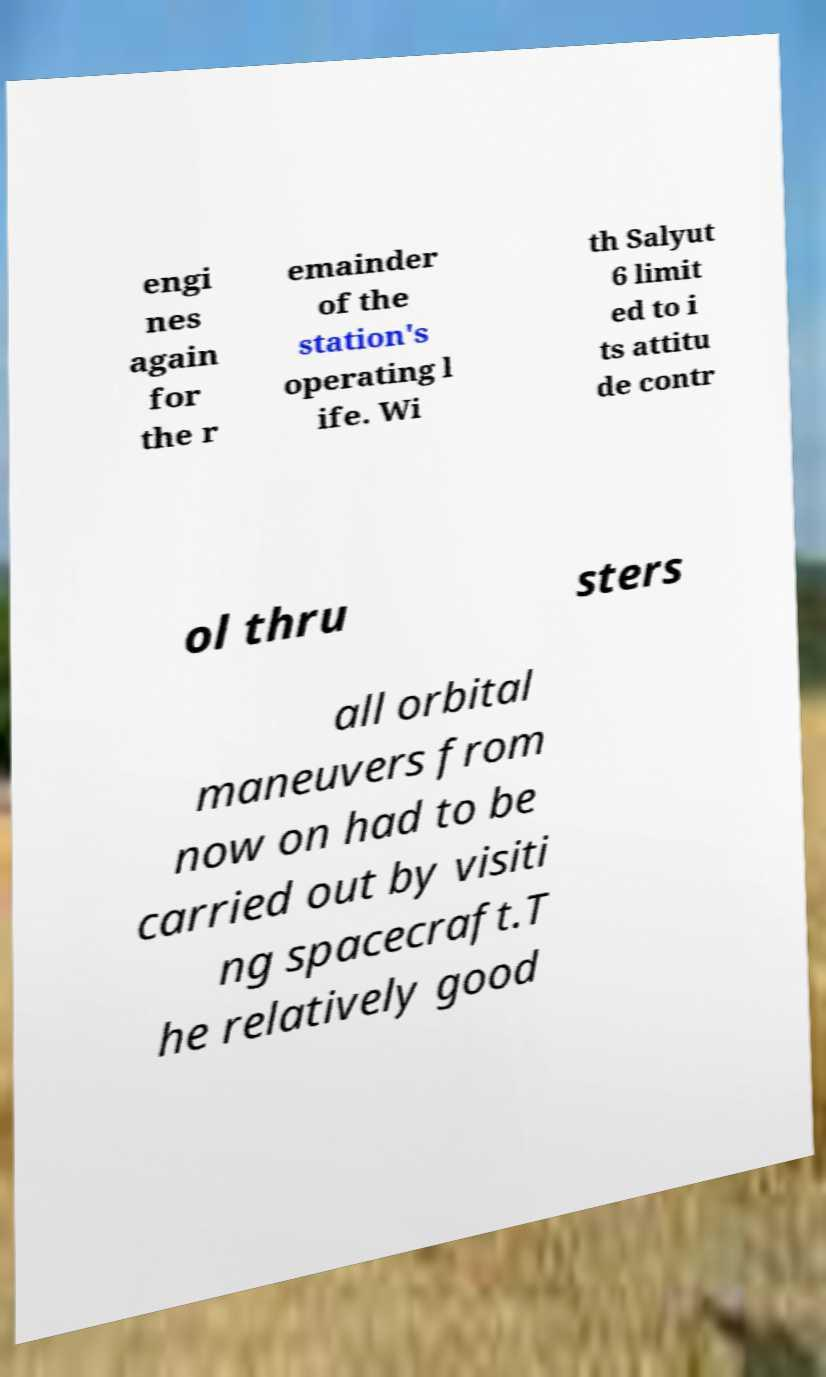Could you assist in decoding the text presented in this image and type it out clearly? engi nes again for the r emainder of the station's operating l ife. Wi th Salyut 6 limit ed to i ts attitu de contr ol thru sters all orbital maneuvers from now on had to be carried out by visiti ng spacecraft.T he relatively good 